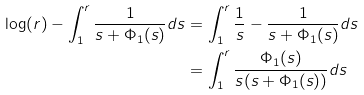<formula> <loc_0><loc_0><loc_500><loc_500>\log ( r ) - \int _ { 1 } ^ { r } \frac { 1 } { s + \Phi _ { 1 } ( s ) } d s & = \int _ { 1 } ^ { r } \frac { 1 } { s } - \frac { 1 } { s + \Phi _ { 1 } ( s ) } d s \\ & = \int _ { 1 } ^ { r } \frac { \Phi _ { 1 } ( s ) } { s ( s + \Phi _ { 1 } ( s ) ) } d s</formula> 